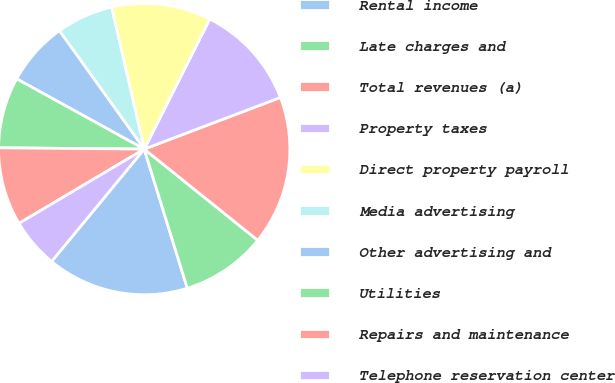Convert chart to OTSL. <chart><loc_0><loc_0><loc_500><loc_500><pie_chart><fcel>Rental income<fcel>Late charges and<fcel>Total revenues (a)<fcel>Property taxes<fcel>Direct property payroll<fcel>Media advertising<fcel>Other advertising and<fcel>Utilities<fcel>Repairs and maintenance<fcel>Telephone reservation center<nl><fcel>15.75%<fcel>9.45%<fcel>16.54%<fcel>11.81%<fcel>11.02%<fcel>6.3%<fcel>7.09%<fcel>7.87%<fcel>8.66%<fcel>5.51%<nl></chart> 